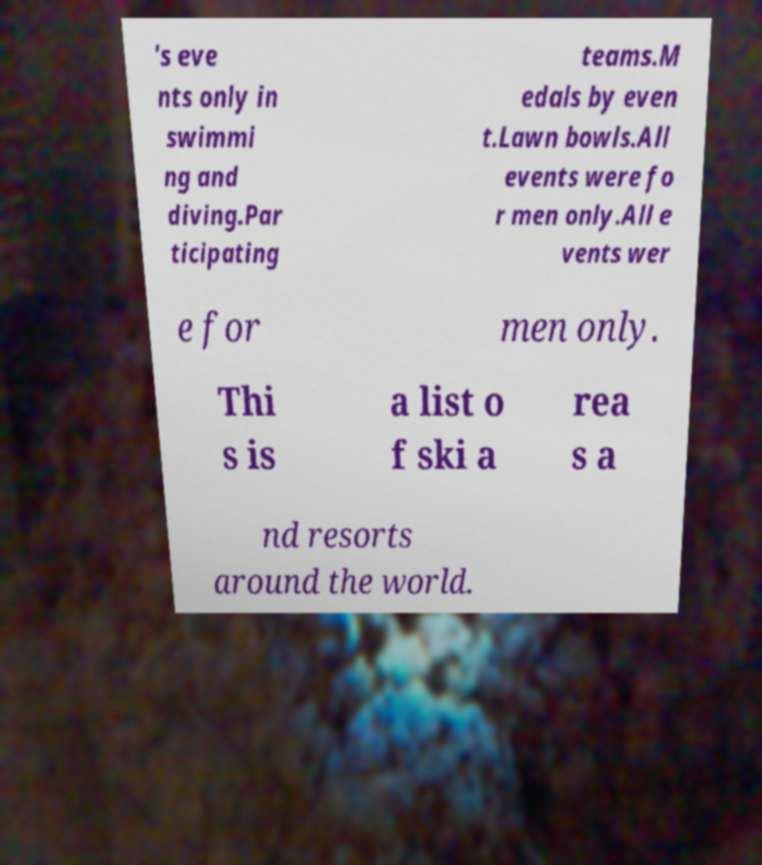Could you extract and type out the text from this image? 's eve nts only in swimmi ng and diving.Par ticipating teams.M edals by even t.Lawn bowls.All events were fo r men only.All e vents wer e for men only. Thi s is a list o f ski a rea s a nd resorts around the world. 